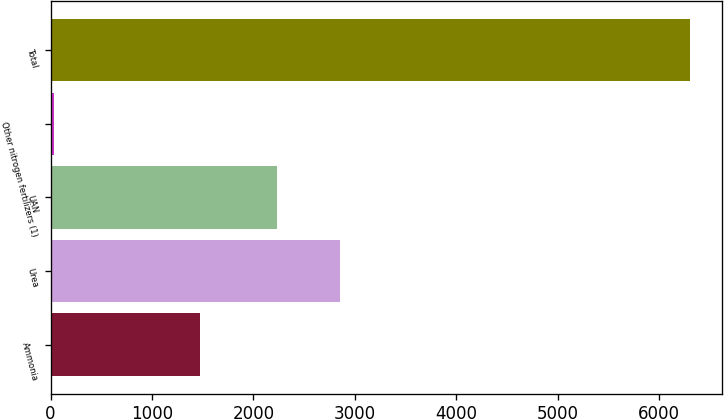<chart> <loc_0><loc_0><loc_500><loc_500><bar_chart><fcel>Ammonia<fcel>Urea<fcel>UAN<fcel>Other nitrogen fertilizers (1)<fcel>Total<nl><fcel>1475<fcel>2855.5<fcel>2228<fcel>34<fcel>6309<nl></chart> 